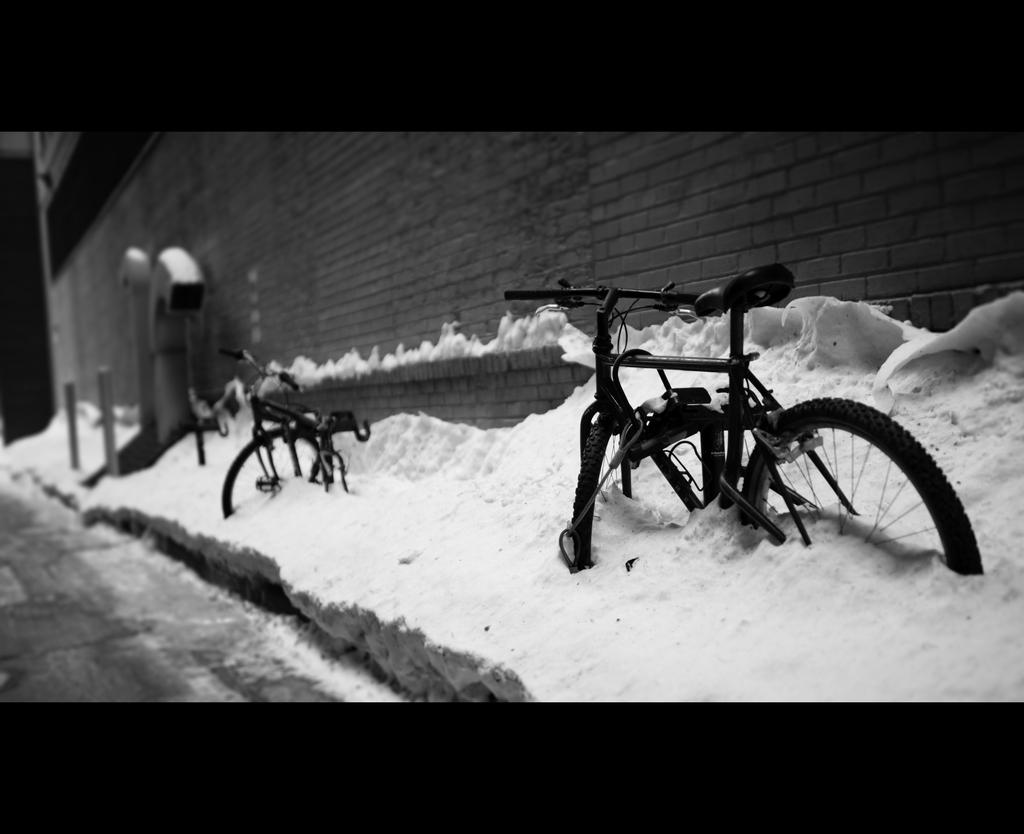What type of vehicles are in the image? There are bicycles in the image. What can be seen in the background of the image? There is a wall and snow in the background of the image. What type of cakes are being served on the zebra in the image? There is no zebra or cakes present in the image. What type of oil is visible on the bicycles in the image? There is no oil visible on the bicycles in the image. 